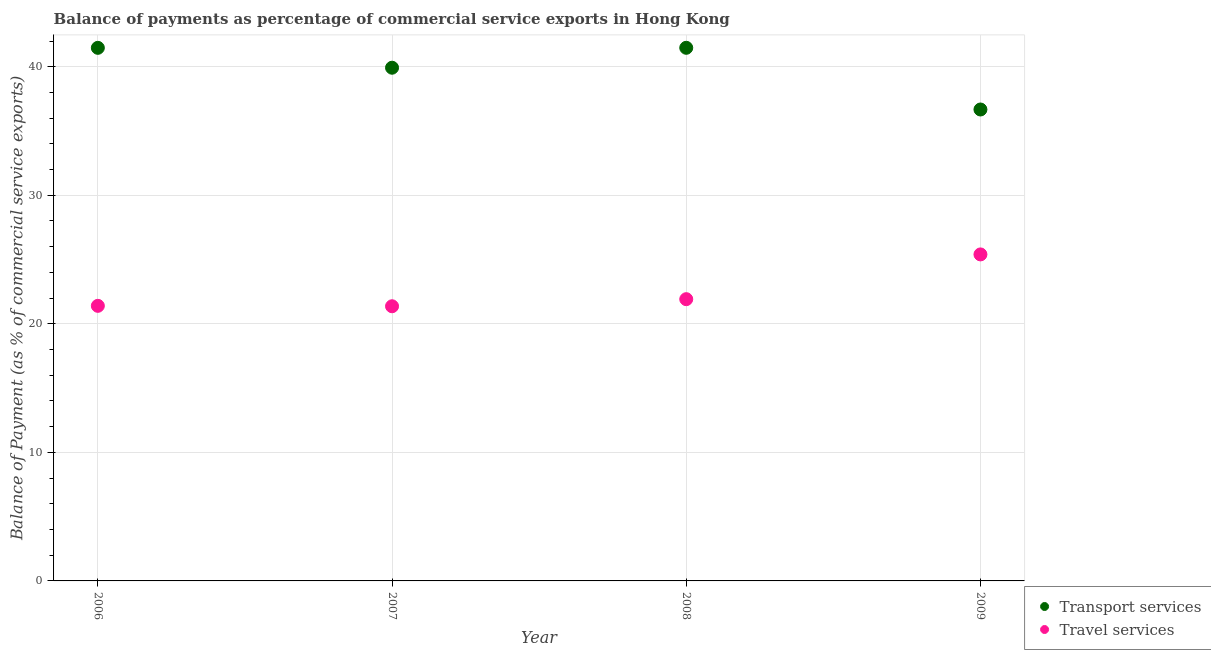How many different coloured dotlines are there?
Offer a very short reply. 2. What is the balance of payments of travel services in 2006?
Provide a succinct answer. 21.4. Across all years, what is the maximum balance of payments of transport services?
Your answer should be very brief. 41.47. Across all years, what is the minimum balance of payments of travel services?
Provide a succinct answer. 21.37. In which year was the balance of payments of travel services maximum?
Give a very brief answer. 2009. In which year was the balance of payments of transport services minimum?
Your response must be concise. 2009. What is the total balance of payments of travel services in the graph?
Your answer should be very brief. 90.08. What is the difference between the balance of payments of travel services in 2006 and that in 2007?
Provide a short and direct response. 0.03. What is the difference between the balance of payments of transport services in 2007 and the balance of payments of travel services in 2006?
Your response must be concise. 18.52. What is the average balance of payments of travel services per year?
Make the answer very short. 22.52. In the year 2007, what is the difference between the balance of payments of transport services and balance of payments of travel services?
Offer a very short reply. 18.56. In how many years, is the balance of payments of transport services greater than 32 %?
Provide a short and direct response. 4. What is the ratio of the balance of payments of travel services in 2008 to that in 2009?
Offer a terse response. 0.86. Is the balance of payments of travel services in 2007 less than that in 2009?
Provide a succinct answer. Yes. Is the difference between the balance of payments of travel services in 2007 and 2009 greater than the difference between the balance of payments of transport services in 2007 and 2009?
Ensure brevity in your answer.  No. What is the difference between the highest and the second highest balance of payments of travel services?
Give a very brief answer. 3.48. What is the difference between the highest and the lowest balance of payments of transport services?
Keep it short and to the point. 4.8. Does the balance of payments of travel services monotonically increase over the years?
Offer a terse response. No. How many dotlines are there?
Provide a succinct answer. 2. Where does the legend appear in the graph?
Offer a terse response. Bottom right. What is the title of the graph?
Offer a very short reply. Balance of payments as percentage of commercial service exports in Hong Kong. What is the label or title of the X-axis?
Keep it short and to the point. Year. What is the label or title of the Y-axis?
Your answer should be compact. Balance of Payment (as % of commercial service exports). What is the Balance of Payment (as % of commercial service exports) in Transport services in 2006?
Offer a very short reply. 41.47. What is the Balance of Payment (as % of commercial service exports) in Travel services in 2006?
Give a very brief answer. 21.4. What is the Balance of Payment (as % of commercial service exports) in Transport services in 2007?
Your answer should be compact. 39.92. What is the Balance of Payment (as % of commercial service exports) in Travel services in 2007?
Offer a very short reply. 21.37. What is the Balance of Payment (as % of commercial service exports) of Transport services in 2008?
Provide a short and direct response. 41.47. What is the Balance of Payment (as % of commercial service exports) of Travel services in 2008?
Offer a very short reply. 21.92. What is the Balance of Payment (as % of commercial service exports) of Transport services in 2009?
Offer a terse response. 36.67. What is the Balance of Payment (as % of commercial service exports) in Travel services in 2009?
Offer a terse response. 25.4. Across all years, what is the maximum Balance of Payment (as % of commercial service exports) in Transport services?
Provide a succinct answer. 41.47. Across all years, what is the maximum Balance of Payment (as % of commercial service exports) in Travel services?
Make the answer very short. 25.4. Across all years, what is the minimum Balance of Payment (as % of commercial service exports) of Transport services?
Give a very brief answer. 36.67. Across all years, what is the minimum Balance of Payment (as % of commercial service exports) of Travel services?
Ensure brevity in your answer.  21.37. What is the total Balance of Payment (as % of commercial service exports) in Transport services in the graph?
Give a very brief answer. 159.53. What is the total Balance of Payment (as % of commercial service exports) in Travel services in the graph?
Ensure brevity in your answer.  90.08. What is the difference between the Balance of Payment (as % of commercial service exports) in Transport services in 2006 and that in 2007?
Your response must be concise. 1.55. What is the difference between the Balance of Payment (as % of commercial service exports) of Travel services in 2006 and that in 2007?
Your answer should be compact. 0.03. What is the difference between the Balance of Payment (as % of commercial service exports) in Transport services in 2006 and that in 2008?
Offer a terse response. -0. What is the difference between the Balance of Payment (as % of commercial service exports) in Travel services in 2006 and that in 2008?
Your response must be concise. -0.52. What is the difference between the Balance of Payment (as % of commercial service exports) in Transport services in 2006 and that in 2009?
Ensure brevity in your answer.  4.8. What is the difference between the Balance of Payment (as % of commercial service exports) of Travel services in 2006 and that in 2009?
Keep it short and to the point. -4. What is the difference between the Balance of Payment (as % of commercial service exports) in Transport services in 2007 and that in 2008?
Give a very brief answer. -1.55. What is the difference between the Balance of Payment (as % of commercial service exports) in Travel services in 2007 and that in 2008?
Your response must be concise. -0.55. What is the difference between the Balance of Payment (as % of commercial service exports) in Transport services in 2007 and that in 2009?
Your response must be concise. 3.25. What is the difference between the Balance of Payment (as % of commercial service exports) of Travel services in 2007 and that in 2009?
Offer a terse response. -4.03. What is the difference between the Balance of Payment (as % of commercial service exports) in Transport services in 2008 and that in 2009?
Ensure brevity in your answer.  4.8. What is the difference between the Balance of Payment (as % of commercial service exports) in Travel services in 2008 and that in 2009?
Give a very brief answer. -3.48. What is the difference between the Balance of Payment (as % of commercial service exports) in Transport services in 2006 and the Balance of Payment (as % of commercial service exports) in Travel services in 2007?
Provide a succinct answer. 20.1. What is the difference between the Balance of Payment (as % of commercial service exports) of Transport services in 2006 and the Balance of Payment (as % of commercial service exports) of Travel services in 2008?
Give a very brief answer. 19.55. What is the difference between the Balance of Payment (as % of commercial service exports) of Transport services in 2006 and the Balance of Payment (as % of commercial service exports) of Travel services in 2009?
Ensure brevity in your answer.  16.07. What is the difference between the Balance of Payment (as % of commercial service exports) in Transport services in 2007 and the Balance of Payment (as % of commercial service exports) in Travel services in 2008?
Give a very brief answer. 18. What is the difference between the Balance of Payment (as % of commercial service exports) in Transport services in 2007 and the Balance of Payment (as % of commercial service exports) in Travel services in 2009?
Your answer should be very brief. 14.52. What is the difference between the Balance of Payment (as % of commercial service exports) in Transport services in 2008 and the Balance of Payment (as % of commercial service exports) in Travel services in 2009?
Provide a succinct answer. 16.07. What is the average Balance of Payment (as % of commercial service exports) of Transport services per year?
Ensure brevity in your answer.  39.88. What is the average Balance of Payment (as % of commercial service exports) in Travel services per year?
Provide a short and direct response. 22.52. In the year 2006, what is the difference between the Balance of Payment (as % of commercial service exports) of Transport services and Balance of Payment (as % of commercial service exports) of Travel services?
Keep it short and to the point. 20.07. In the year 2007, what is the difference between the Balance of Payment (as % of commercial service exports) of Transport services and Balance of Payment (as % of commercial service exports) of Travel services?
Keep it short and to the point. 18.56. In the year 2008, what is the difference between the Balance of Payment (as % of commercial service exports) of Transport services and Balance of Payment (as % of commercial service exports) of Travel services?
Provide a succinct answer. 19.55. In the year 2009, what is the difference between the Balance of Payment (as % of commercial service exports) in Transport services and Balance of Payment (as % of commercial service exports) in Travel services?
Give a very brief answer. 11.27. What is the ratio of the Balance of Payment (as % of commercial service exports) of Transport services in 2006 to that in 2007?
Your answer should be compact. 1.04. What is the ratio of the Balance of Payment (as % of commercial service exports) in Travel services in 2006 to that in 2008?
Provide a succinct answer. 0.98. What is the ratio of the Balance of Payment (as % of commercial service exports) in Transport services in 2006 to that in 2009?
Your response must be concise. 1.13. What is the ratio of the Balance of Payment (as % of commercial service exports) in Travel services in 2006 to that in 2009?
Offer a very short reply. 0.84. What is the ratio of the Balance of Payment (as % of commercial service exports) of Transport services in 2007 to that in 2008?
Your answer should be very brief. 0.96. What is the ratio of the Balance of Payment (as % of commercial service exports) in Travel services in 2007 to that in 2008?
Give a very brief answer. 0.97. What is the ratio of the Balance of Payment (as % of commercial service exports) in Transport services in 2007 to that in 2009?
Your answer should be very brief. 1.09. What is the ratio of the Balance of Payment (as % of commercial service exports) in Travel services in 2007 to that in 2009?
Keep it short and to the point. 0.84. What is the ratio of the Balance of Payment (as % of commercial service exports) of Transport services in 2008 to that in 2009?
Provide a short and direct response. 1.13. What is the ratio of the Balance of Payment (as % of commercial service exports) of Travel services in 2008 to that in 2009?
Provide a short and direct response. 0.86. What is the difference between the highest and the second highest Balance of Payment (as % of commercial service exports) in Transport services?
Ensure brevity in your answer.  0. What is the difference between the highest and the second highest Balance of Payment (as % of commercial service exports) of Travel services?
Offer a very short reply. 3.48. What is the difference between the highest and the lowest Balance of Payment (as % of commercial service exports) of Transport services?
Make the answer very short. 4.8. What is the difference between the highest and the lowest Balance of Payment (as % of commercial service exports) in Travel services?
Provide a succinct answer. 4.03. 